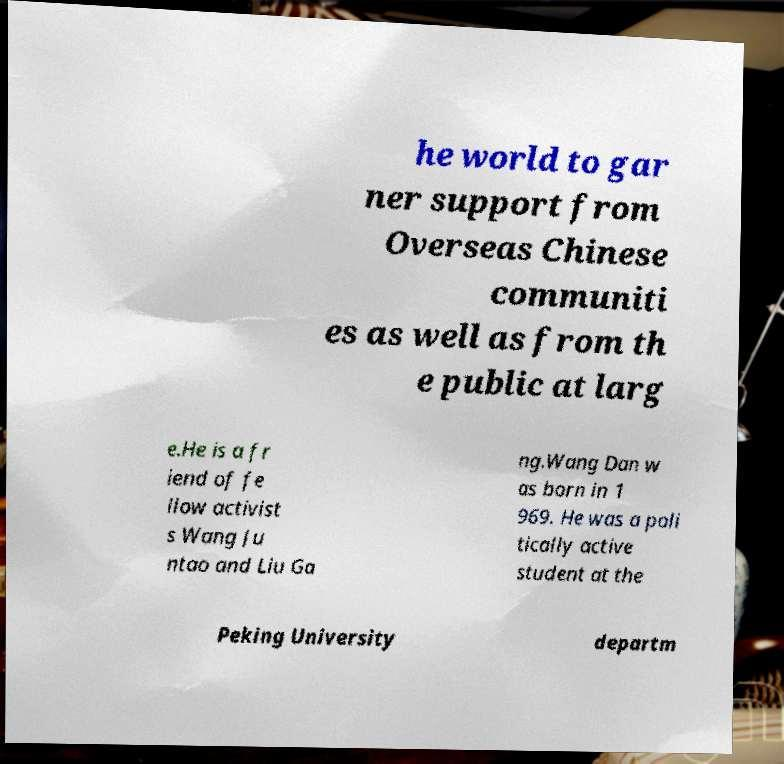There's text embedded in this image that I need extracted. Can you transcribe it verbatim? he world to gar ner support from Overseas Chinese communiti es as well as from th e public at larg e.He is a fr iend of fe llow activist s Wang Ju ntao and Liu Ga ng.Wang Dan w as born in 1 969. He was a poli tically active student at the Peking University departm 